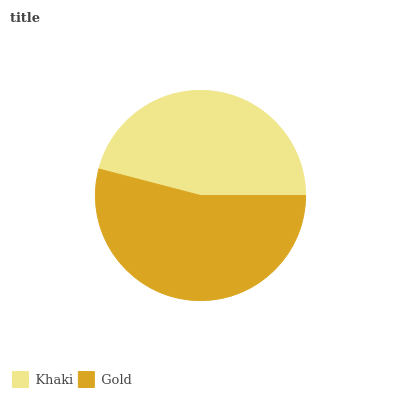Is Khaki the minimum?
Answer yes or no. Yes. Is Gold the maximum?
Answer yes or no. Yes. Is Gold the minimum?
Answer yes or no. No. Is Gold greater than Khaki?
Answer yes or no. Yes. Is Khaki less than Gold?
Answer yes or no. Yes. Is Khaki greater than Gold?
Answer yes or no. No. Is Gold less than Khaki?
Answer yes or no. No. Is Gold the high median?
Answer yes or no. Yes. Is Khaki the low median?
Answer yes or no. Yes. Is Khaki the high median?
Answer yes or no. No. Is Gold the low median?
Answer yes or no. No. 